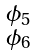<formula> <loc_0><loc_0><loc_500><loc_500>\begin{smallmatrix} \phi _ { 5 } \\ \phi _ { 6 } \end{smallmatrix}</formula> 